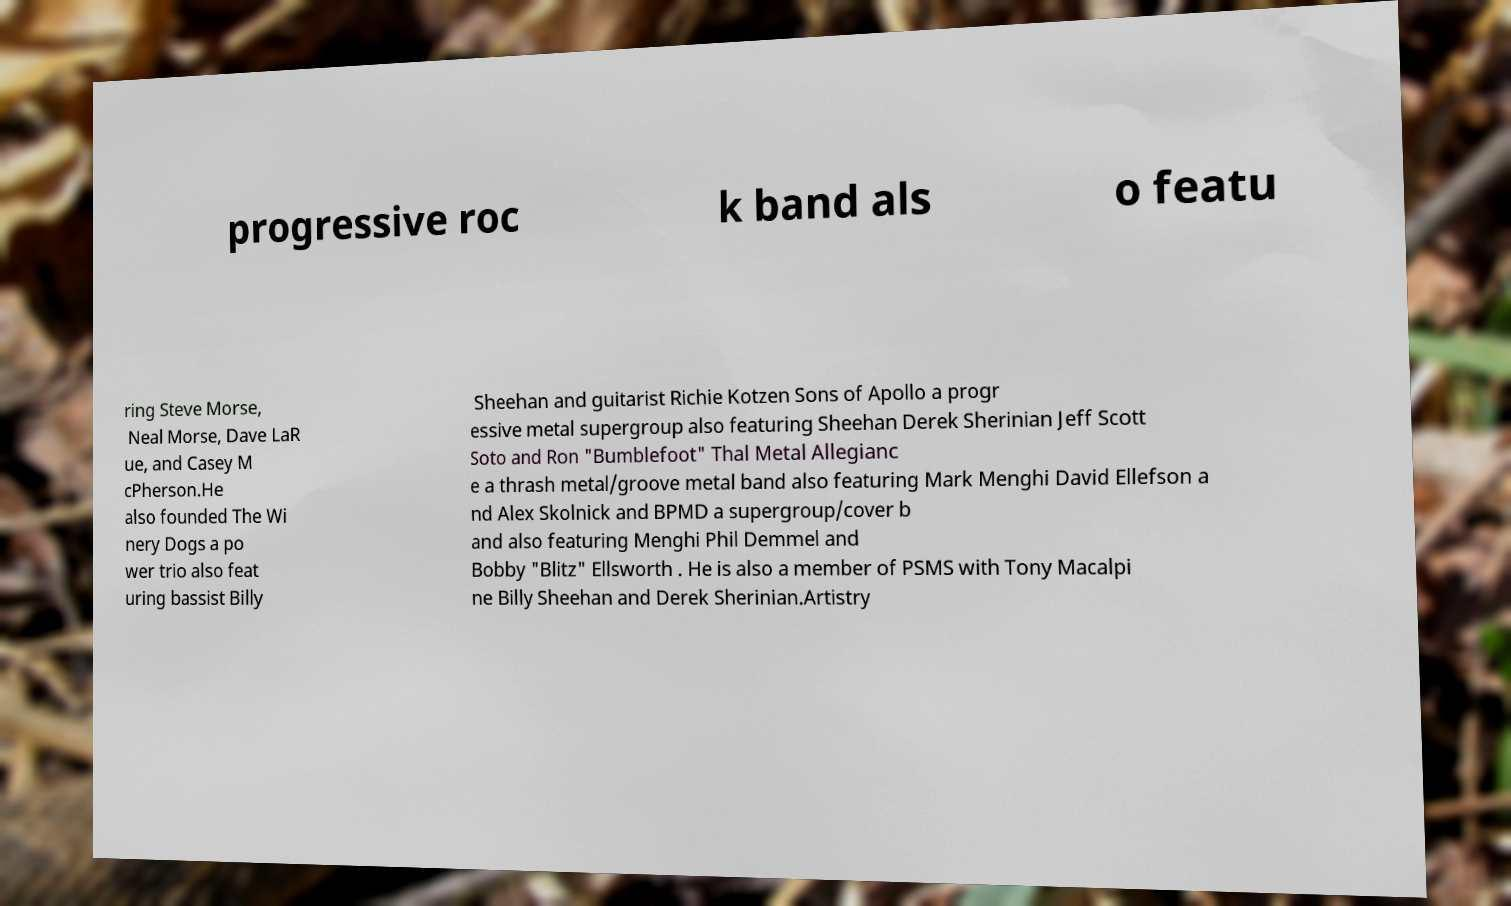For documentation purposes, I need the text within this image transcribed. Could you provide that? progressive roc k band als o featu ring Steve Morse, Neal Morse, Dave LaR ue, and Casey M cPherson.He also founded The Wi nery Dogs a po wer trio also feat uring bassist Billy Sheehan and guitarist Richie Kotzen Sons of Apollo a progr essive metal supergroup also featuring Sheehan Derek Sherinian Jeff Scott Soto and Ron "Bumblefoot" Thal Metal Allegianc e a thrash metal/groove metal band also featuring Mark Menghi David Ellefson a nd Alex Skolnick and BPMD a supergroup/cover b and also featuring Menghi Phil Demmel and Bobby "Blitz" Ellsworth . He is also a member of PSMS with Tony Macalpi ne Billy Sheehan and Derek Sherinian.Artistry 